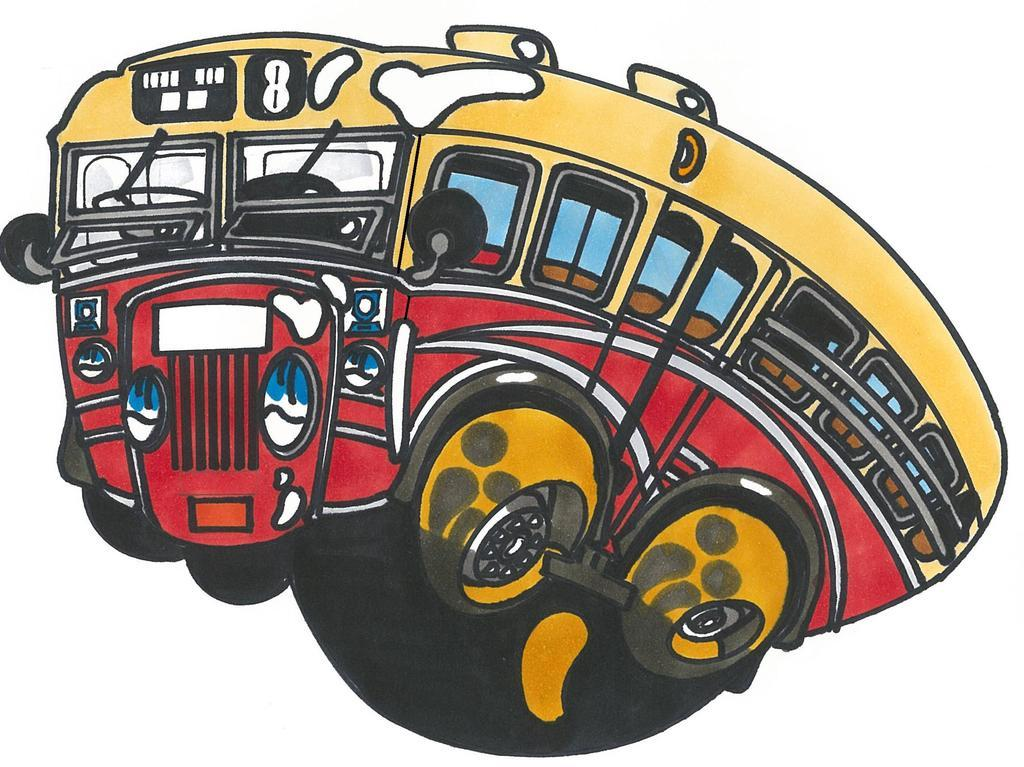What type of image is shown in the picture? The image is a clipart. What is the main subject of the clipart? The clipart depicts a bus. What colors are used to represent the bus in the clipart? The bus is in yellow and red colors. Where is the rod and nut used in the clipart? There is no rod or nut present in the clipart; it only depicts a bus in yellow and red colors. What type of furniture can be seen in the bedroom in the clipart? There is no bedroom or furniture present in the clipart; it only depicts a bus. 